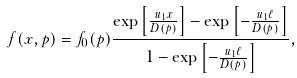<formula> <loc_0><loc_0><loc_500><loc_500>f ( x , p ) = f _ { 0 } ( p ) \frac { \exp \left [ \frac { u _ { 1 } x } { D ( p ) } \right ] - \exp \left [ - \frac { u _ { 1 } \ell } { D ( p ) } \right ] } { 1 - \exp \left [ - \frac { u _ { 1 } \ell } { D ( p ) } \right ] } ,</formula> 